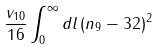Convert formula to latex. <formula><loc_0><loc_0><loc_500><loc_500>\frac { v _ { 1 0 } } { 1 6 } \int _ { 0 } ^ { \infty } d l \, ( n _ { 9 } - 3 2 ) ^ { 2 }</formula> 